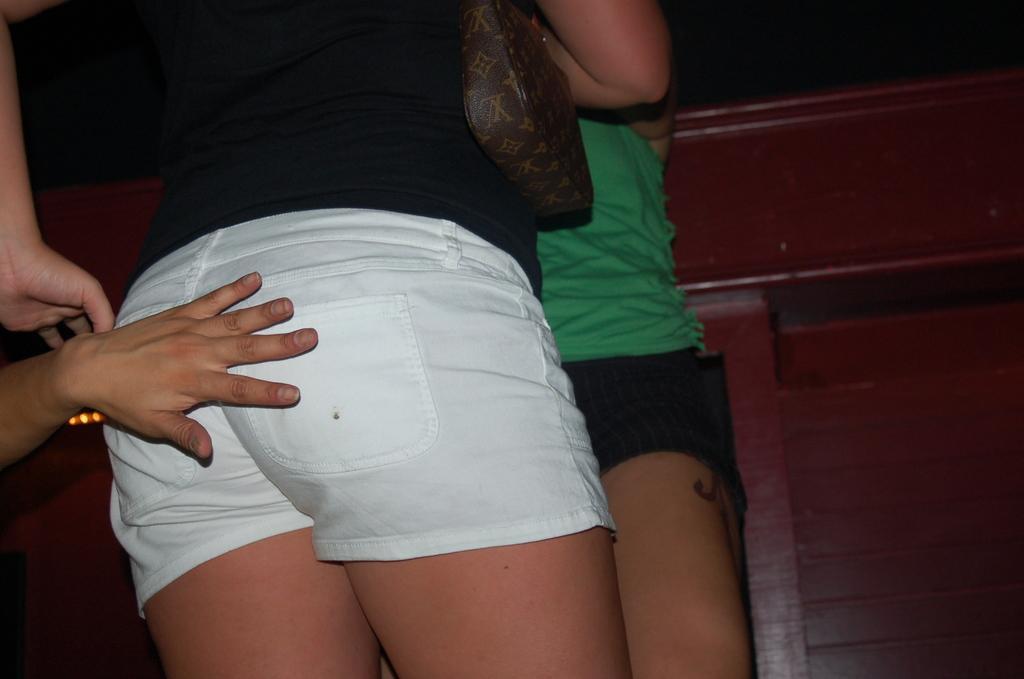Describe this image in one or two sentences. In this image, I can see two persons standing. On the left side of the image, I can see a person´s hand. In the background, there is a wooden object. 